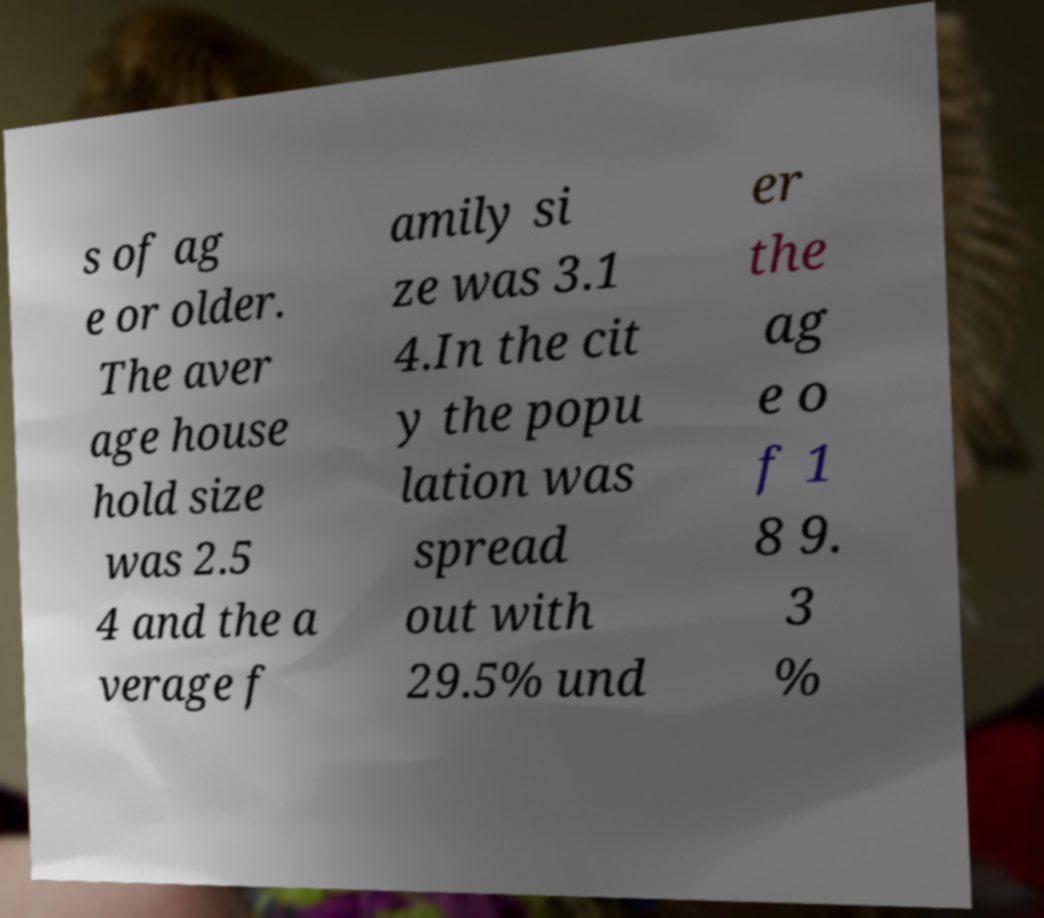What messages or text are displayed in this image? I need them in a readable, typed format. s of ag e or older. The aver age house hold size was 2.5 4 and the a verage f amily si ze was 3.1 4.In the cit y the popu lation was spread out with 29.5% und er the ag e o f 1 8 9. 3 % 